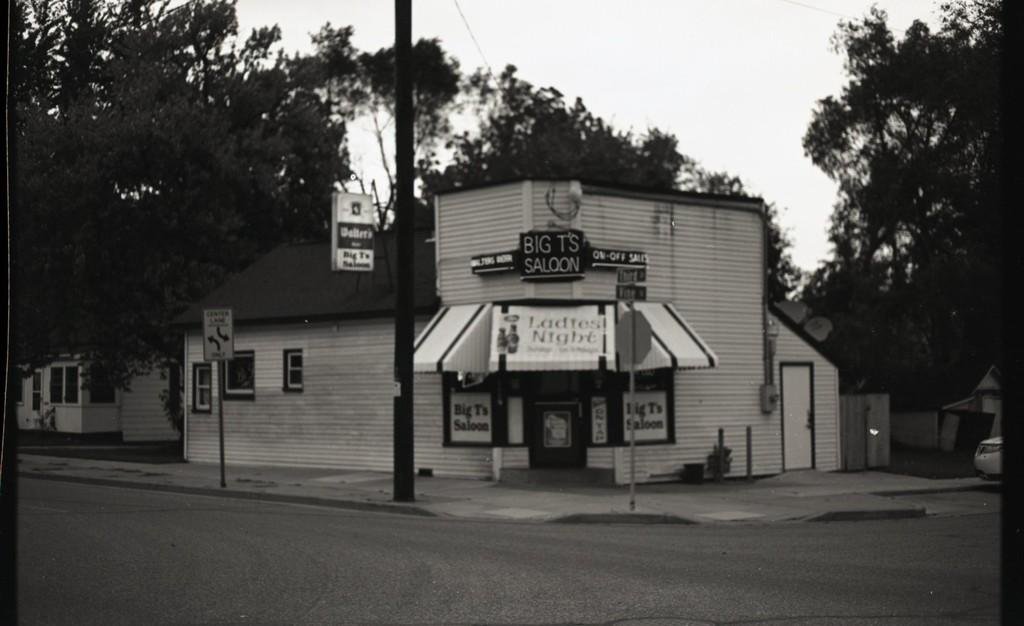What is the color scheme of the image? The image is black and white. What can be seen running through the image? There is a road in the image. What structures are present along the road? There are poles and shops in the image. What type of vegetation is visible in the image? There are trees in the image. What is visible at the top of the image? The sky is visible in the image. How many fingers can be seen pointing at the channel in the image? There are no fingers or channels present in the image. What type of roll is being used to navigate the image? There is no roll or navigation device present in the image. 